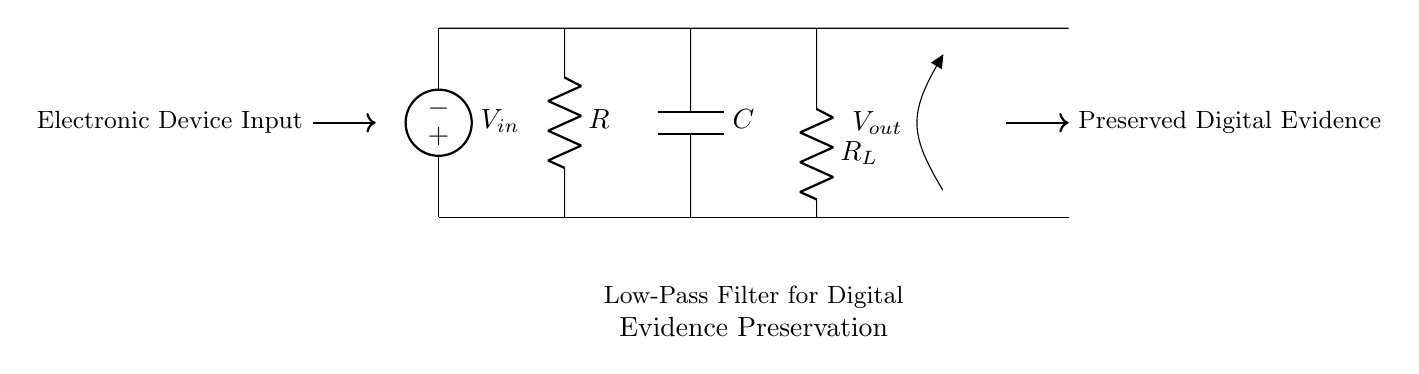What is the type of filter shown in this circuit? The circuit diagram depicts a low-pass filter, which allows signals with a frequency lower than a certain cutoff frequency to pass through while attenuating higher frequencies. The label 'Low-Pass Filter' in the diagram clarifies this.
Answer: Low-Pass Filter What component is labeled R? The component labeled R in the circuit is a resistor, which is used to limit current or divide voltage in a circuit. It is marked in the diagram and is part of the filter network.
Answer: Resistor What is the purpose of the capacitor C? The capacitor, labeled C, in the low-pass filter serves to store electrical energy temporarily and allows AC signals to pass while blocking DC signals. In the context of a low-pass filter, it especially helps filter out high frequencies.
Answer: Store energy What is the output voltage Vout representing? The output voltage Vout represents the voltage across the load resistor R_L, which gives an indication of the filtered signal after passing through the low-pass filter. This output is where the preserved digital evidence can be measured.
Answer: Filtered signal Which component acts as a load in this circuit? The component that acts as a load in this circuit is labeled R_L. This load resistor takes the filtered output from the low-pass filter, and it represents how load affects the overall response of the filter.
Answer: Load Resistor How do current and voltage interact in this filter? The current in the circuit follows through the source, R, C, and R_L, where resistive components determine the voltage drop according to Ohm's law (V=IR). In a low-pass filter, voltage varies depending on frequency, affecting the resultant current passing to the output.
Answer: Varies with frequency What happens to high-frequency signals in this circuit? High-frequency signals are attenuated by the low-pass filter, meaning that as frequency increases beyond the cutoff point, these signals are significantly reduced in amplitude at the output, which is essential for preserving lower-frequency digital evidence.
Answer: Attenuated 